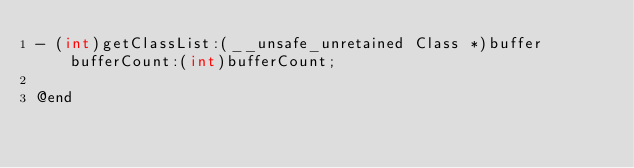Convert code to text. <code><loc_0><loc_0><loc_500><loc_500><_C_>- (int)getClassList:(__unsafe_unretained Class *)buffer bufferCount:(int)bufferCount;

@end
</code> 